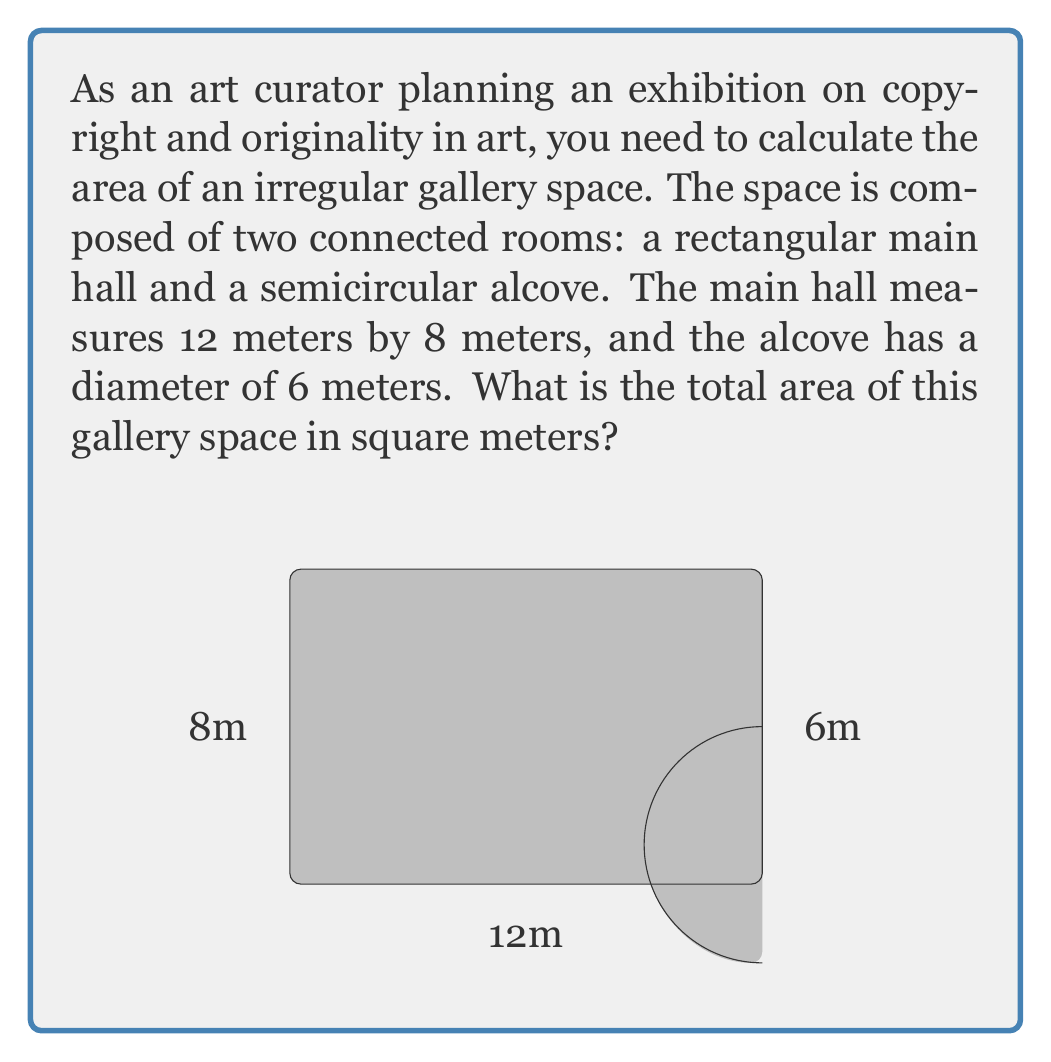Solve this math problem. To find the total area of this irregular gallery space, we need to calculate the areas of the rectangular main hall and the semicircular alcove separately, then add them together.

1. Area of the rectangular main hall:
   $A_{rectangle} = length \times width$
   $A_{rectangle} = 12 \text{ m} \times 8 \text{ m} = 96 \text{ m}^2$

2. Area of the semicircular alcove:
   The area of a full circle is $\pi r^2$, where $r$ is the radius.
   The diameter is 6 m, so the radius is 3 m.
   For a semicircle, we take half of this area:
   $A_{semicircle} = \frac{1}{2} \pi r^2$
   $A_{semicircle} = \frac{1}{2} \pi (3 \text{ m})^2 = \frac{9\pi}{2} \text{ m}^2 \approx 14.14 \text{ m}^2$

3. Total area:
   $A_{total} = A_{rectangle} + A_{semicircle}$
   $A_{total} = 96 \text{ m}^2 + \frac{9\pi}{2} \text{ m}^2$
   $A_{total} = 96 + \frac{9\pi}{2} \text{ m}^2 \approx 110.14 \text{ m}^2$

Therefore, the total area of the gallery space is $96 + \frac{9\pi}{2}$ square meters, or approximately 110.14 square meters.
Answer: $96 + \frac{9\pi}{2} \text{ m}^2 \approx 110.14 \text{ m}^2$ 